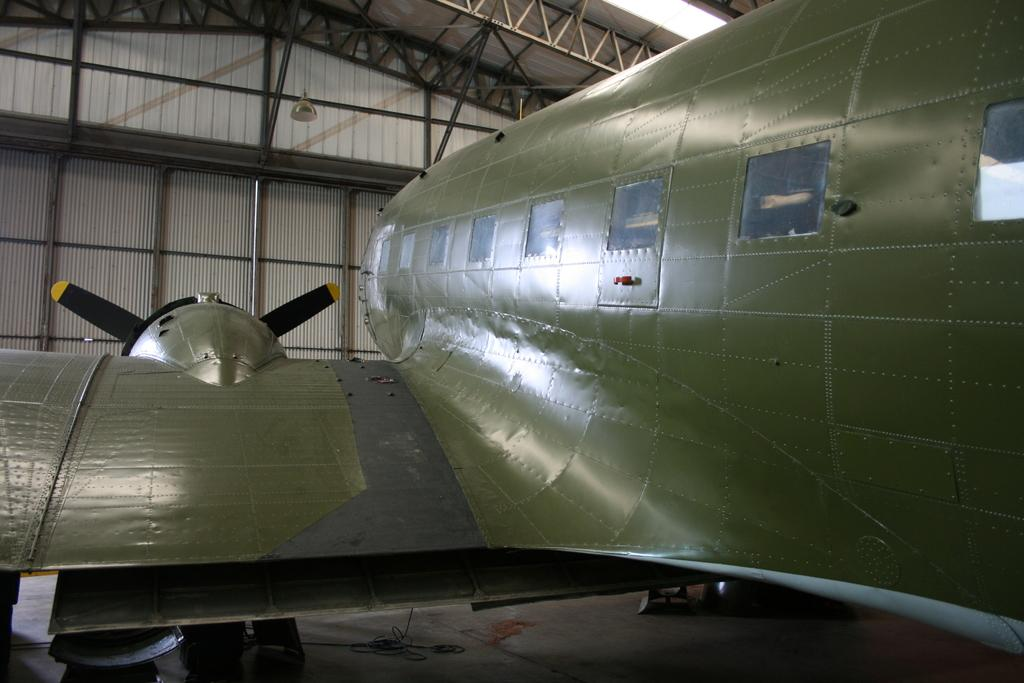What is the main subject of the image? There is an object that resembles an aeroplane in the image. Can you describe any other structures or objects in the image? There is an iron shed on the left side of the image. What type of leather is used to make the robin's nest in the image? There is no robin or nest present in the image, so it is not possible to determine what type of leather might be used. 